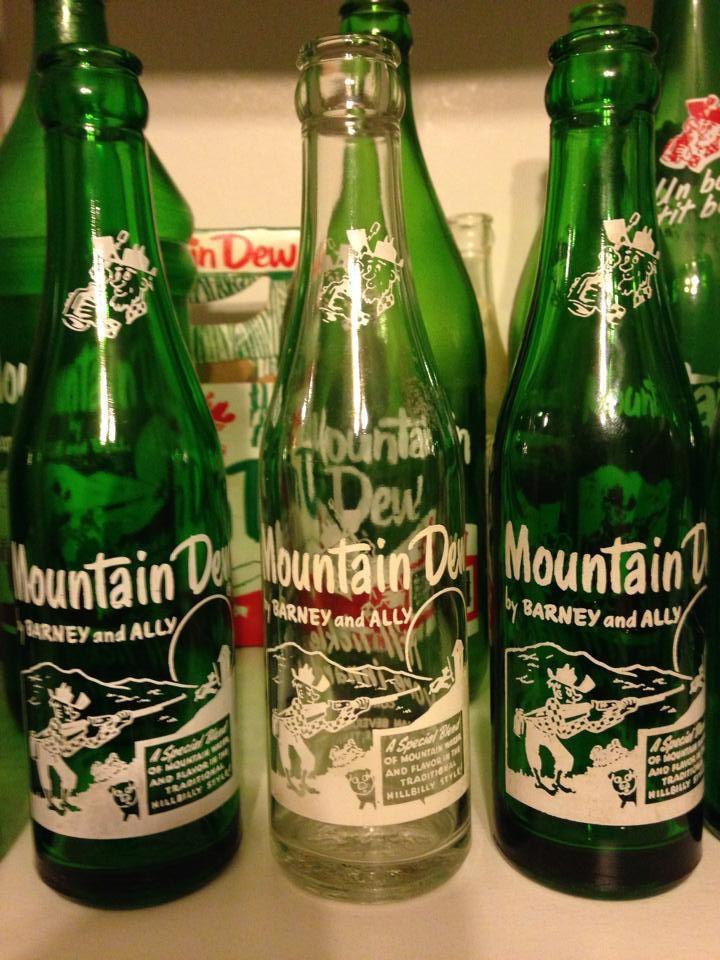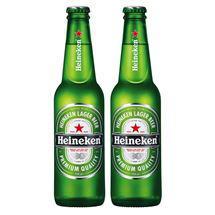The first image is the image on the left, the second image is the image on the right. For the images displayed, is the sentence "An image contains exactly two bottles, both green and the same height." factually correct? Answer yes or no. Yes. The first image is the image on the left, the second image is the image on the right. Considering the images on both sides, is "The image on the right shows two green glass bottles" valid? Answer yes or no. Yes. 